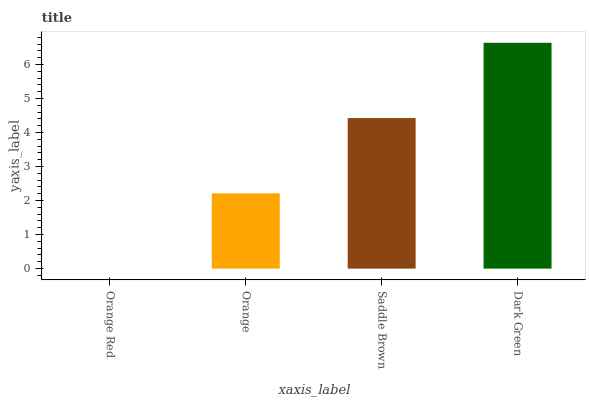Is Orange Red the minimum?
Answer yes or no. Yes. Is Dark Green the maximum?
Answer yes or no. Yes. Is Orange the minimum?
Answer yes or no. No. Is Orange the maximum?
Answer yes or no. No. Is Orange greater than Orange Red?
Answer yes or no. Yes. Is Orange Red less than Orange?
Answer yes or no. Yes. Is Orange Red greater than Orange?
Answer yes or no. No. Is Orange less than Orange Red?
Answer yes or no. No. Is Saddle Brown the high median?
Answer yes or no. Yes. Is Orange the low median?
Answer yes or no. Yes. Is Orange the high median?
Answer yes or no. No. Is Dark Green the low median?
Answer yes or no. No. 